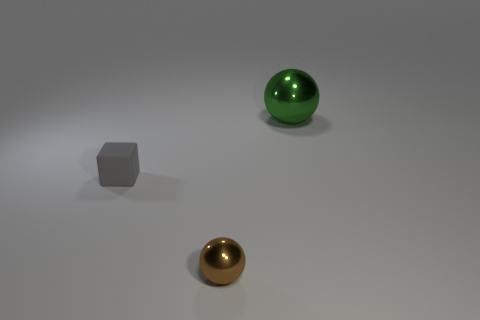What material is the small object that is on the right side of the small gray rubber object on the left side of the brown sphere made of?
Your response must be concise. Metal. What shape is the other matte thing that is the same size as the brown object?
Your response must be concise. Cube. Are there fewer small brown balls than large blue metallic objects?
Provide a short and direct response. No. Is there a large green shiny ball that is right of the metal ball in front of the gray matte cube?
Give a very brief answer. Yes. What shape is the big green object that is the same material as the brown sphere?
Make the answer very short. Sphere. Is there any other thing that is the same color as the tiny metal object?
Provide a short and direct response. No. What is the material of the other object that is the same shape as the large green object?
Provide a succinct answer. Metal. What number of other objects are there of the same size as the matte cube?
Provide a succinct answer. 1. There is a metallic object that is behind the tiny gray block; is its shape the same as the brown object?
Make the answer very short. Yes. How many other objects are there of the same shape as the small gray matte thing?
Your answer should be very brief. 0. 